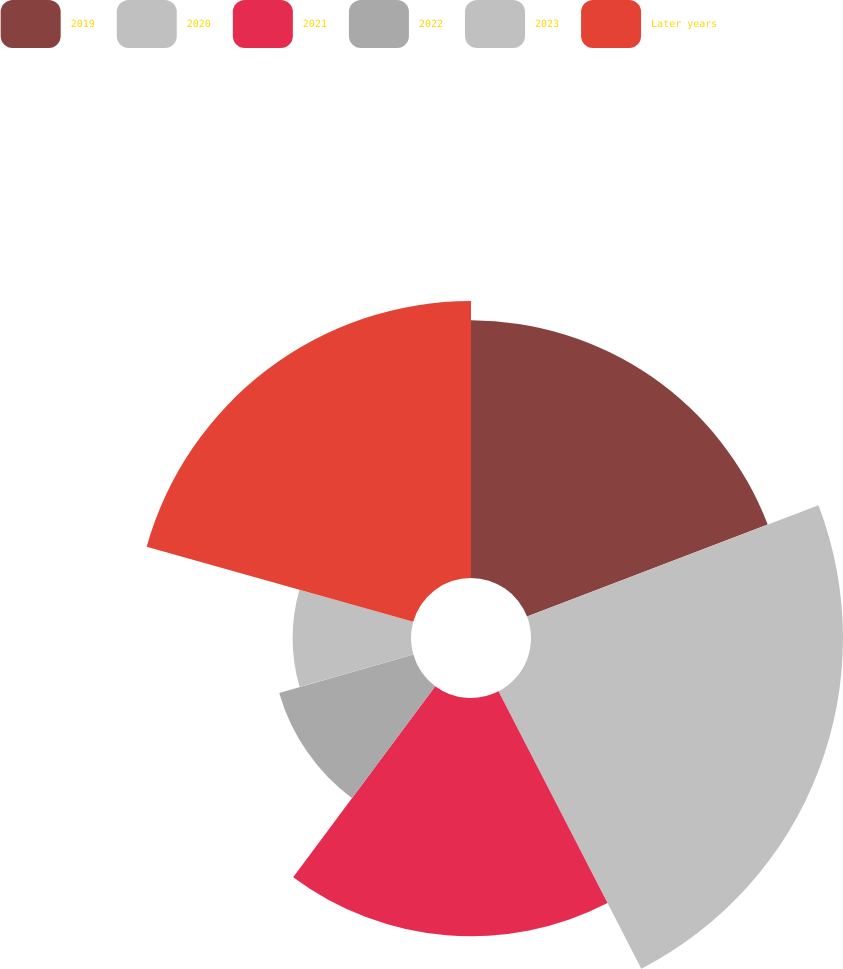Convert chart. <chart><loc_0><loc_0><loc_500><loc_500><pie_chart><fcel>2019<fcel>2020<fcel>2021<fcel>2022<fcel>2023<fcel>Later years<nl><fcel>19.19%<fcel>23.24%<fcel>17.74%<fcel>10.39%<fcel>8.81%<fcel>20.63%<nl></chart> 